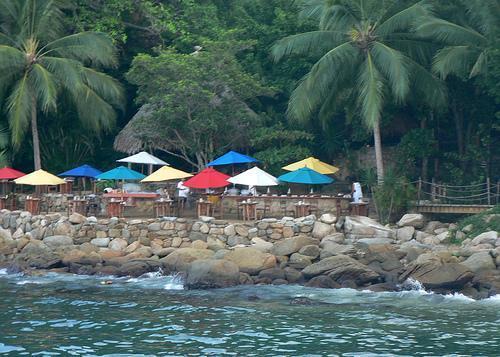How many umbrellas?
Give a very brief answer. 11. How many colors are the umbrellas?
Give a very brief answer. 5. How many yellow umbrellas?
Give a very brief answer. 3. How many red umbrellas?
Give a very brief answer. 2. How many different colors of umbrella are there?
Give a very brief answer. 5. How many yellow umbrellas are there?
Give a very brief answer. 3. How many trains are there?
Give a very brief answer. 0. 